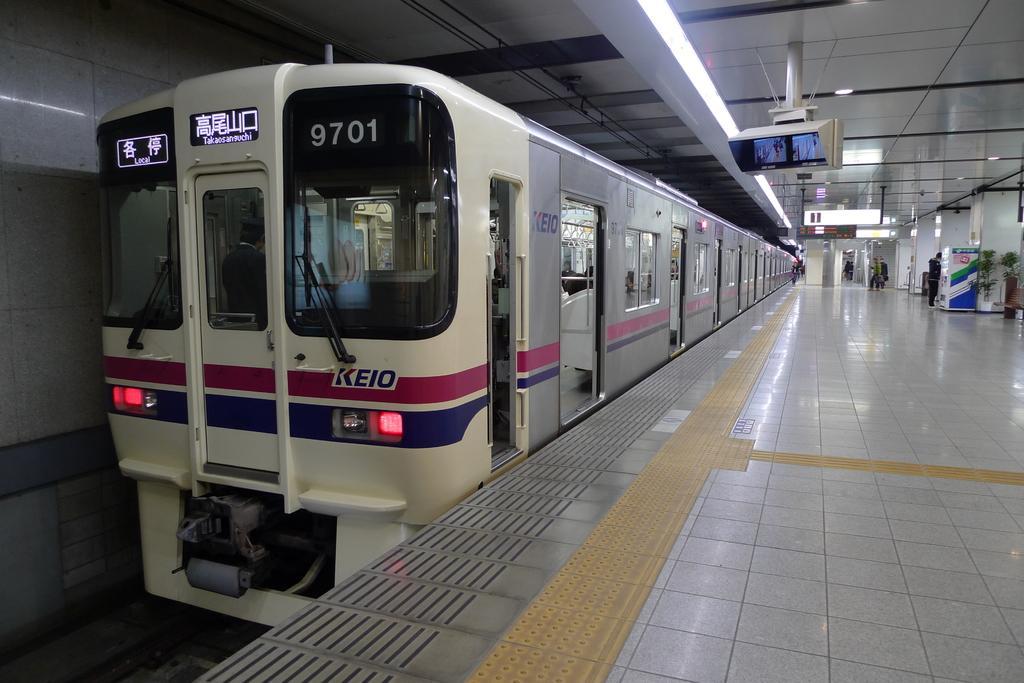In one or two sentences, can you explain what this image depicts? In this image, I can see a train on the railway track. This is a platform. I think this is a screen, which is hanging to the ceiling. There are few people standing. These are the plants and the pillars. I can see the name boards hanging. I think this picture was taken inside the railway station. 